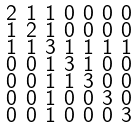<formula> <loc_0><loc_0><loc_500><loc_500>\begin{smallmatrix} 2 & 1 & 1 & 0 & 0 & 0 & 0 \\ 1 & 2 & 1 & 0 & 0 & 0 & 0 \\ 1 & 1 & 3 & 1 & 1 & 1 & 1 \\ 0 & 0 & 1 & 3 & 1 & 0 & 0 \\ 0 & 0 & 1 & 1 & 3 & 0 & 0 \\ 0 & 0 & 1 & 0 & 0 & 3 & 0 \\ 0 & 0 & 1 & 0 & 0 & 0 & 3 \end{smallmatrix}</formula> 